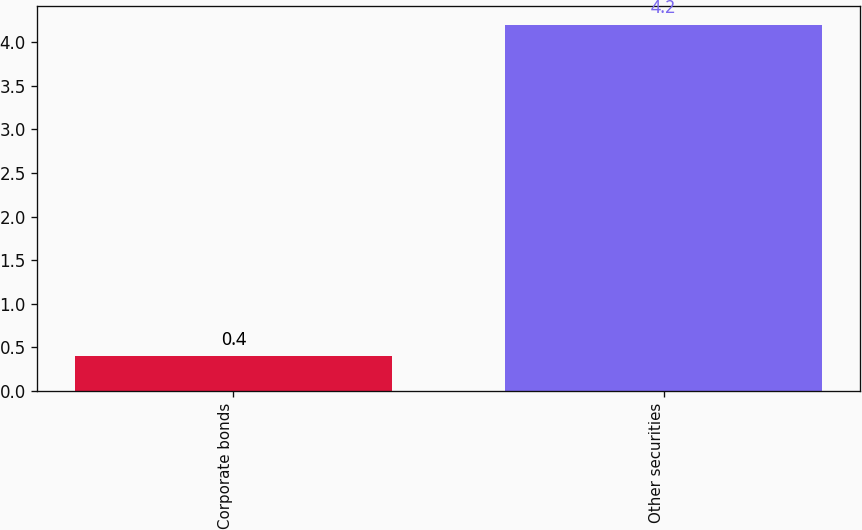Convert chart to OTSL. <chart><loc_0><loc_0><loc_500><loc_500><bar_chart><fcel>Corporate bonds<fcel>Other securities<nl><fcel>0.4<fcel>4.2<nl></chart> 